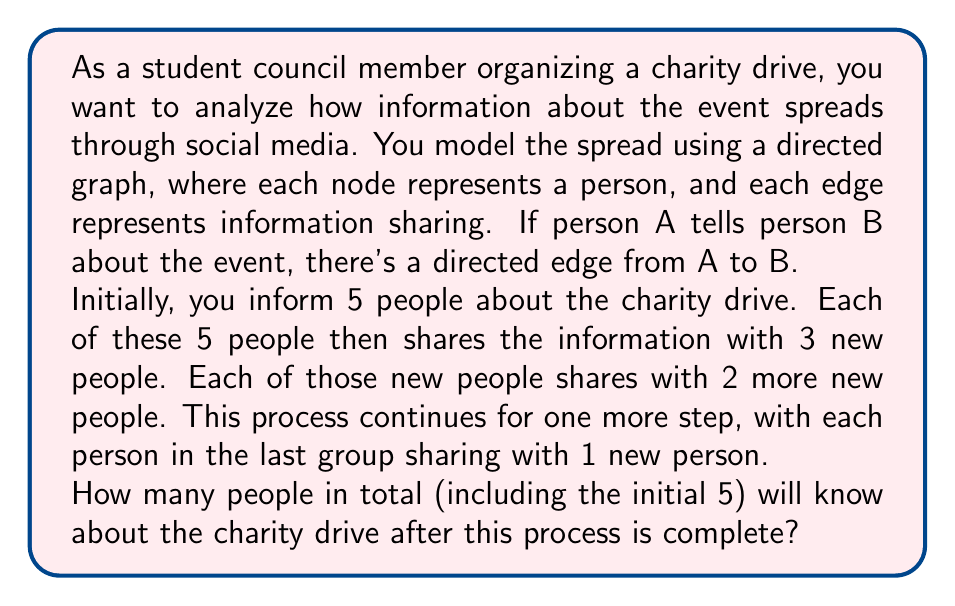Provide a solution to this math problem. Let's break this down step-by-step:

1) Initial step: 5 people are informed.

2) First sharing step:
   Each of the 5 initial people informs 3 new people.
   Number of new people informed: $5 \times 3 = 15$
   Total informed after this step: $5 + 15 = 20$

3) Second sharing step:
   Each of the 15 people from the previous step informs 2 new people.
   Number of new people informed: $15 \times 2 = 30$
   Total informed after this step: $20 + 30 = 50$

4) Third sharing step:
   Each of the 30 people from the previous step informs 1 new person.
   Number of new people informed: $30 \times 1 = 30$
   Total informed after this step: $50 + 30 = 80$

We can represent this as a graph where each level corresponds to a sharing step:

[asy]
unitsize(1cm);

void drawNode(pair p) {
  fill(p, circle(0.1));
}

for (int i = 0; i < 5; ++i) {
  drawNode((i-2, 3));
}

for (int i = 0; i < 15; ++i) {
  drawNode((i-7, 2));
}

for (int i = 0; i < 30; ++i) {
  drawNode((i-14.5, 1));
}

for (int i = 0; i < 30; ++i) {
  drawNode((i-14.5, 0));
}

draw((0,3)--(0,0), dashed);
label("...", (0,-0.5));
[/asy]

The total number of people informed is the sum of people at each level:
$$5 + 15 + 30 + 30 = 80$$

Thus, after the process is complete, 80 people will know about the charity drive.
Answer: 80 people 